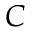<formula> <loc_0><loc_0><loc_500><loc_500>C</formula> 